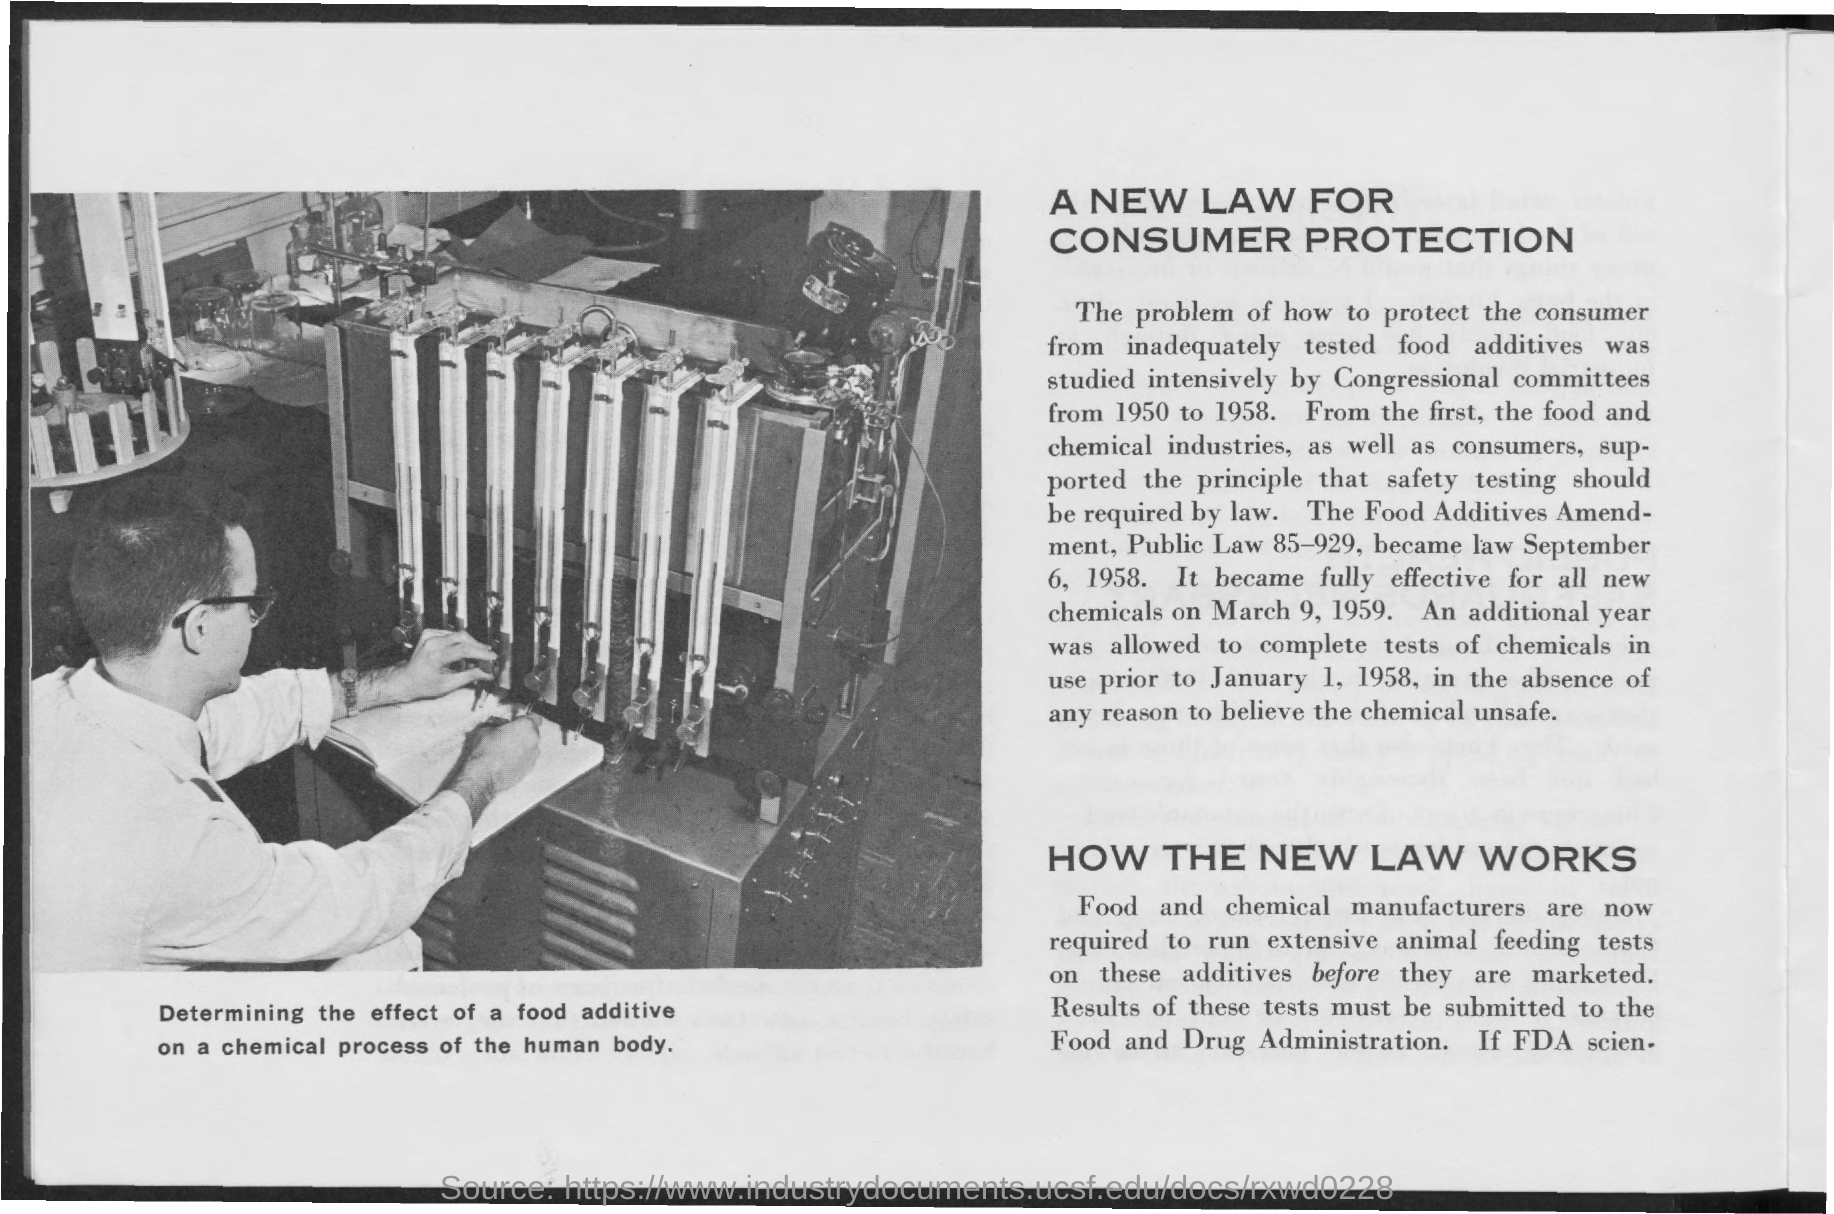Highlight a few significant elements in this photo. The second title in the document is 'How the new Law Works.' The first title in the document is 'A new law for consumer protection.' 